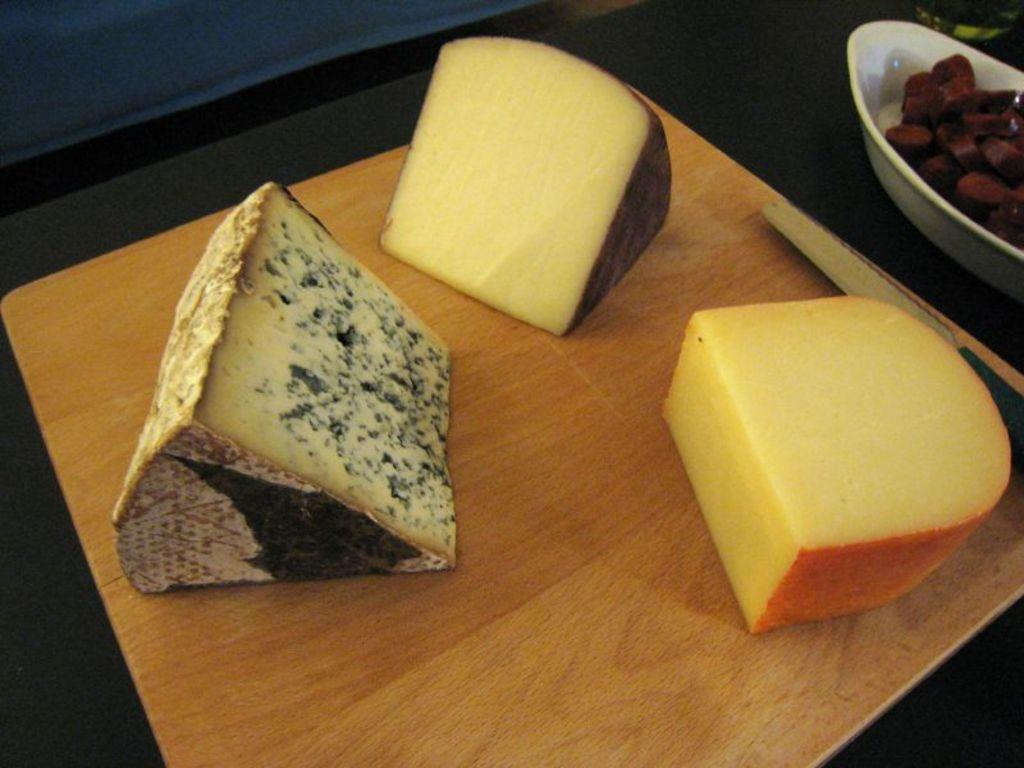Can you describe this image briefly? In this we can see some pieces of cheese and a knife placed on a table. We can also see a bowl of chopped vegetables beside it. 